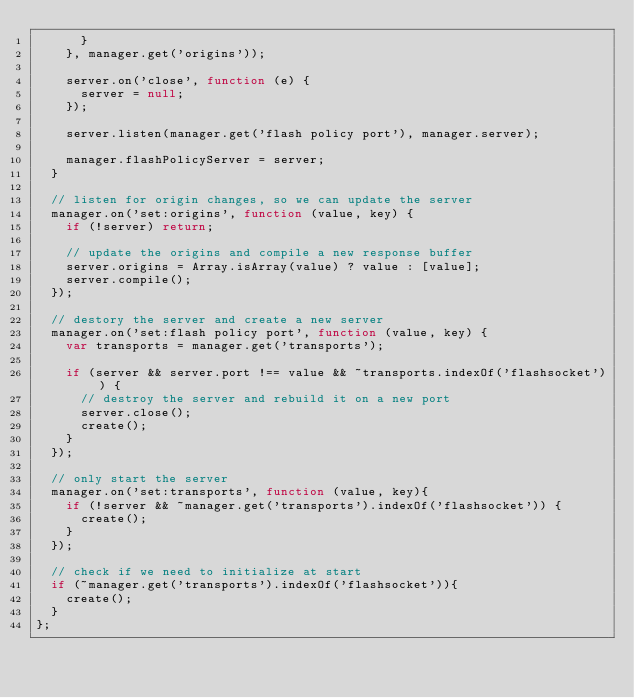Convert code to text. <code><loc_0><loc_0><loc_500><loc_500><_JavaScript_>      }
    }, manager.get('origins'));

    server.on('close', function (e) {
      server = null;
    });

    server.listen(manager.get('flash policy port'), manager.server);

    manager.flashPolicyServer = server;
  }

  // listen for origin changes, so we can update the server
  manager.on('set:origins', function (value, key) {
    if (!server) return;

    // update the origins and compile a new response buffer
    server.origins = Array.isArray(value) ? value : [value];
    server.compile();
  });

  // destory the server and create a new server
  manager.on('set:flash policy port', function (value, key) {
    var transports = manager.get('transports');

    if (server && server.port !== value && ~transports.indexOf('flashsocket')) {
      // destroy the server and rebuild it on a new port
      server.close();
      create();
    }
  });

  // only start the server
  manager.on('set:transports', function (value, key){
    if (!server && ~manager.get('transports').indexOf('flashsocket')) {
      create();
    }
  });

  // check if we need to initialize at start
  if (~manager.get('transports').indexOf('flashsocket')){
    create();
  }
};
</code> 